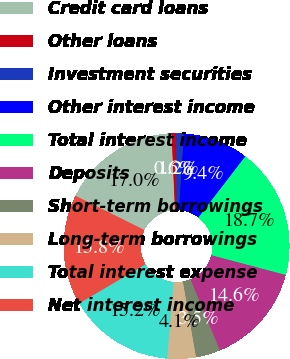<chart> <loc_0><loc_0><loc_500><loc_500><pie_chart><fcel>Credit card loans<fcel>Other loans<fcel>Investment securities<fcel>Other interest income<fcel>Total interest income<fcel>Deposits<fcel>Short-term borrowings<fcel>Long-term borrowings<fcel>Total interest expense<fcel>Net interest income<nl><fcel>16.96%<fcel>0.58%<fcel>1.17%<fcel>9.36%<fcel>18.71%<fcel>14.62%<fcel>3.51%<fcel>4.09%<fcel>15.2%<fcel>15.79%<nl></chart> 